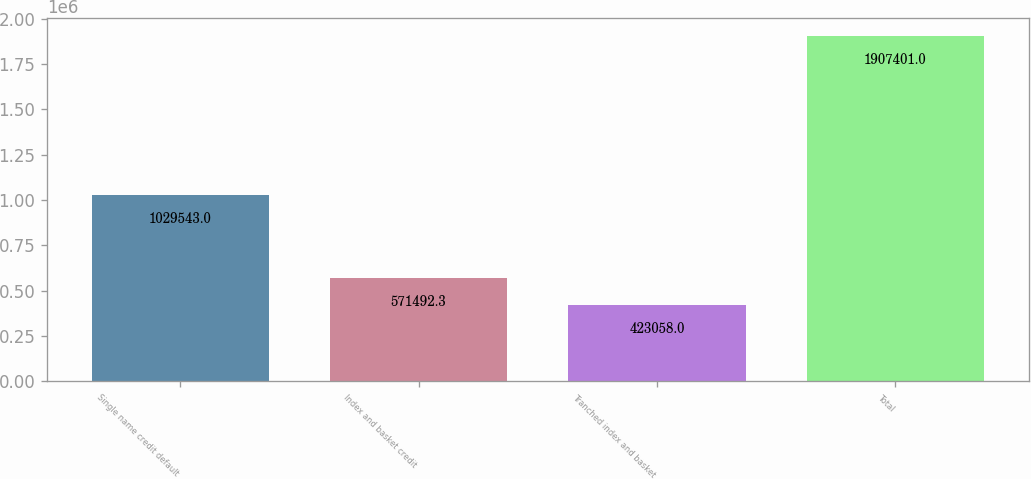<chart> <loc_0><loc_0><loc_500><loc_500><bar_chart><fcel>Single name credit default<fcel>Index and basket credit<fcel>Tranched index and basket<fcel>Total<nl><fcel>1.02954e+06<fcel>571492<fcel>423058<fcel>1.9074e+06<nl></chart> 